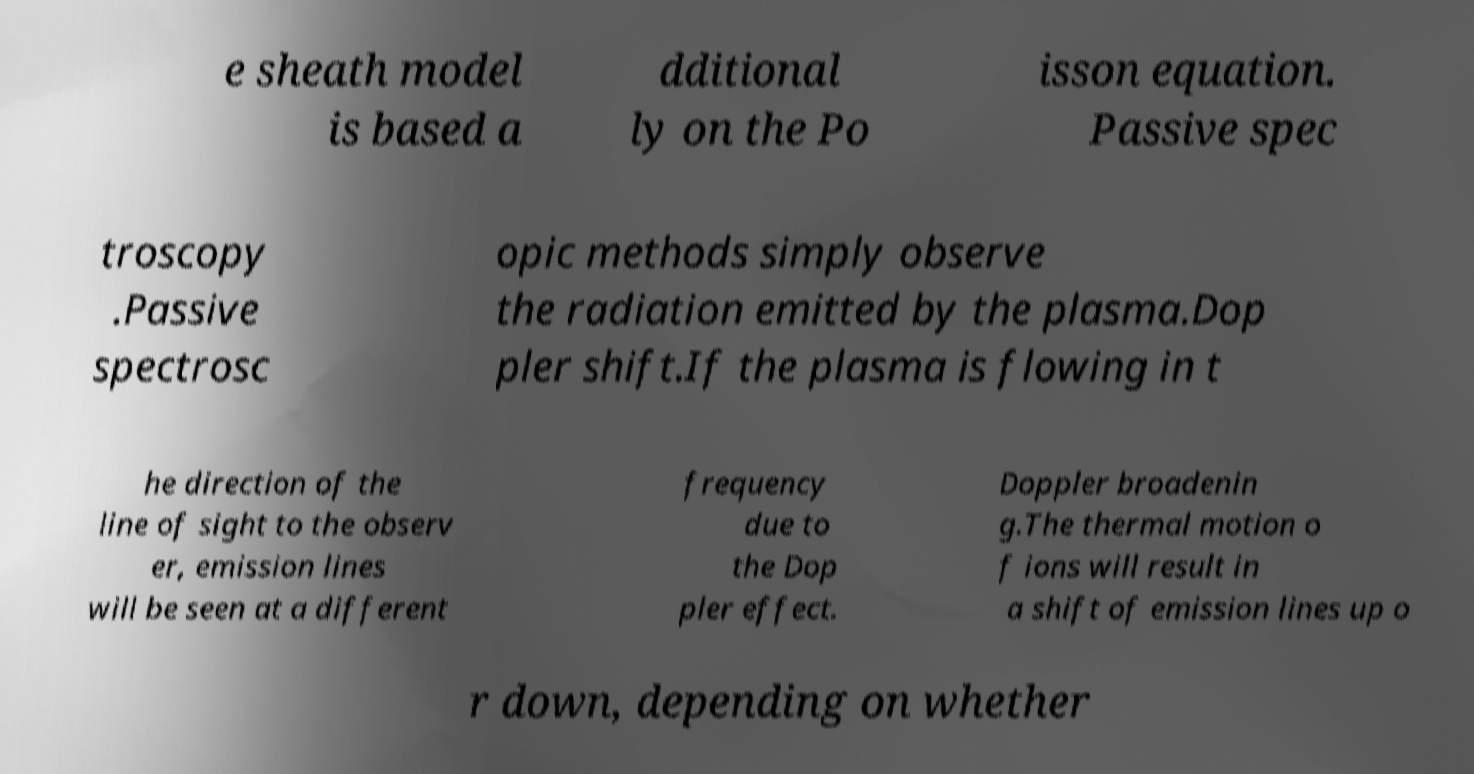I need the written content from this picture converted into text. Can you do that? e sheath model is based a dditional ly on the Po isson equation. Passive spec troscopy .Passive spectrosc opic methods simply observe the radiation emitted by the plasma.Dop pler shift.If the plasma is flowing in t he direction of the line of sight to the observ er, emission lines will be seen at a different frequency due to the Dop pler effect. Doppler broadenin g.The thermal motion o f ions will result in a shift of emission lines up o r down, depending on whether 